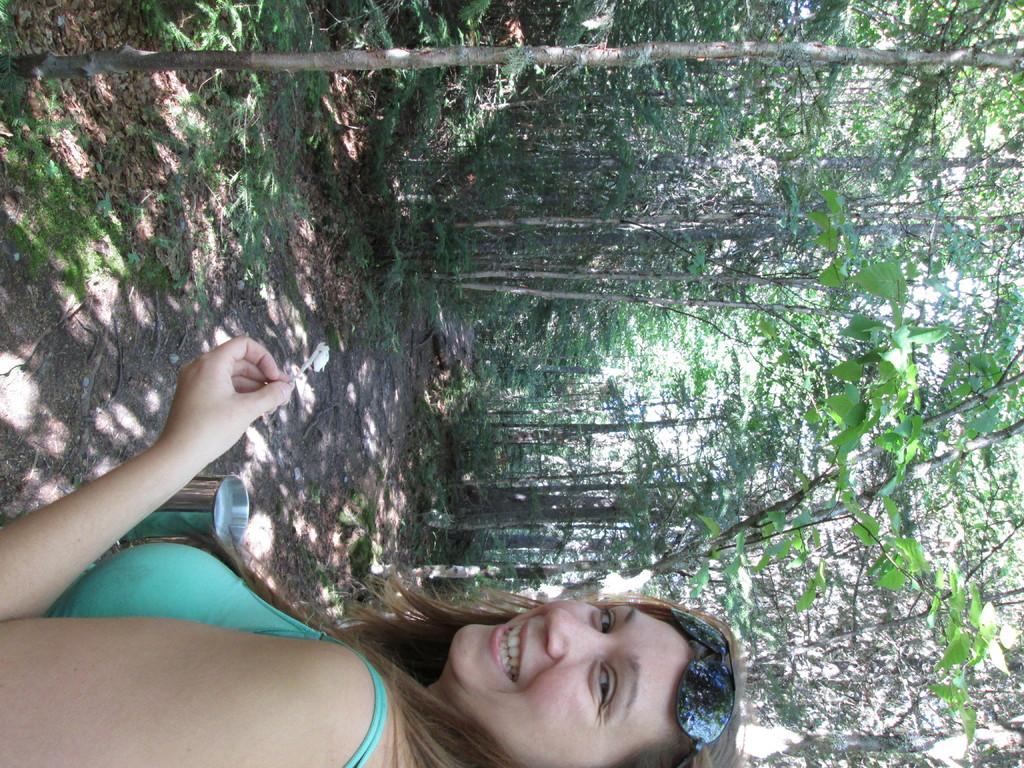What is the woman holding in the image? The woman is holding a glass at the bottom of the image. What can be seen in the background of the image? There are trees, plants, and grass in the background of the image. What type of toe is visible in the image? There is no toe visible in the image; it only shows a woman holding a glass and the background. 